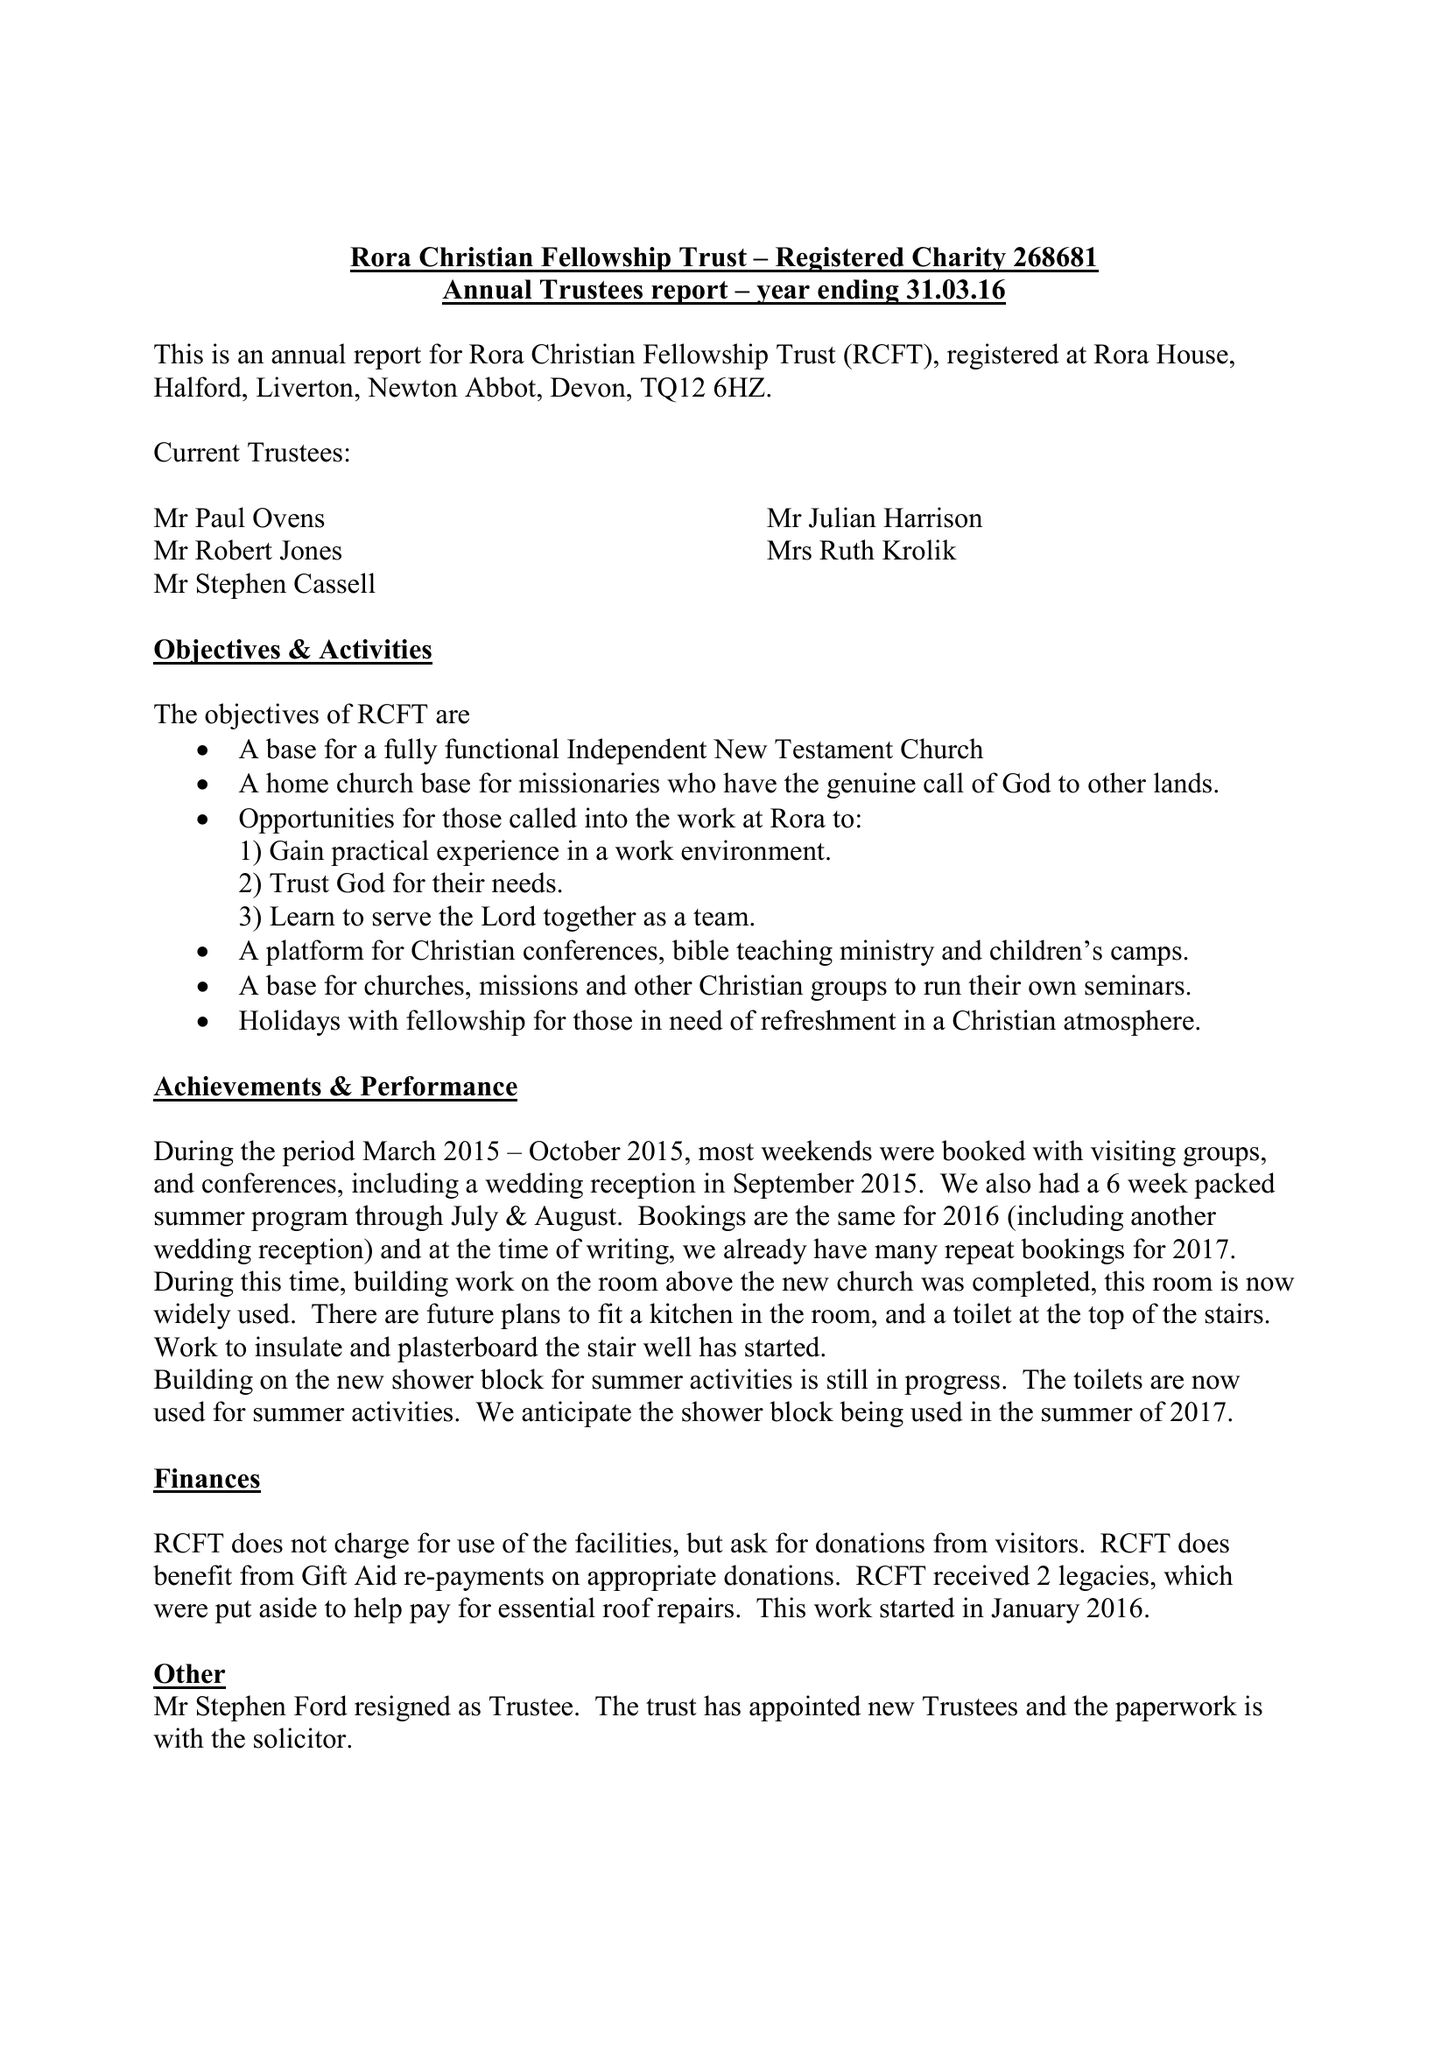What is the value for the address__post_town?
Answer the question using a single word or phrase. NEWTON ABBOT 